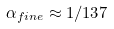<formula> <loc_0><loc_0><loc_500><loc_500>\alpha _ { f i n e } \approx 1 / 1 3 7</formula> 